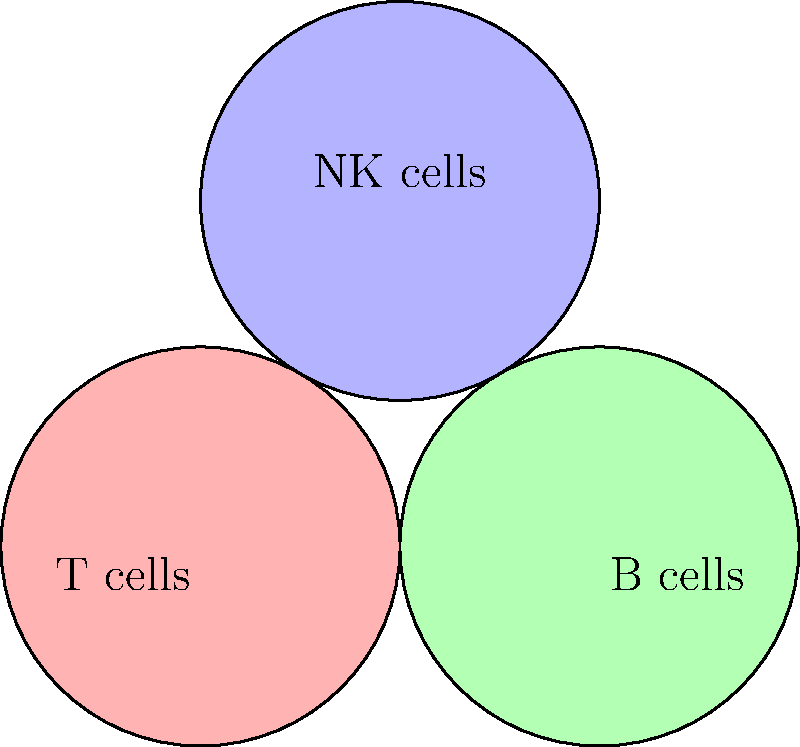In a study of immune cell populations, a Venn diagram is created using three overlapping circles representing T cells, B cells, and Natural Killer (NK) cells. Each circle has a radius of 1 unit, and their centers form an equilateral triangle with side length 2 units. What is the area of the region where all three cell populations overlap, rounded to three decimal places? To solve this problem, we need to follow these steps:

1) First, we need to understand that the area where all three circles overlap is the intersection of three circles.

2) The centers of the circles form an equilateral triangle with side length 2. This means the distance between any two centers is 2 units.

3) To find the area of overlap, we can use the formula for the area of intersection of three circles:

   $A = 3(R^2 \arccos(\frac{d}{2R}) - \frac{d}{2}\sqrt{R^2 - \frac{d^2}{4}}) - \pi R^2$

   Where:
   $A$ is the area of intersection
   $R$ is the radius of each circle
   $d$ is the distance between the centers of any two circles

4) We know that $R = 1$ and $d = 2$. Let's substitute these values:

   $A = 3(1^2 \arccos(\frac{2}{2(1)}) - \frac{2}{2}\sqrt{1^2 - \frac{2^2}{4}}) - \pi (1^2)$

5) Simplify:
   $A = 3(\arccos(1) - \sqrt{1 - 1}) - \pi$

6) $\arccos(1) = 0$, so this simplifies to:
   $A = 3(0 - 0) - \pi = -\pi$

7) The area can't be negative, so we take the absolute value:
   $A = \pi \approx 3.14159$

8) Rounding to three decimal places:
   $A \approx 3.142$
Answer: 3.142 square units 